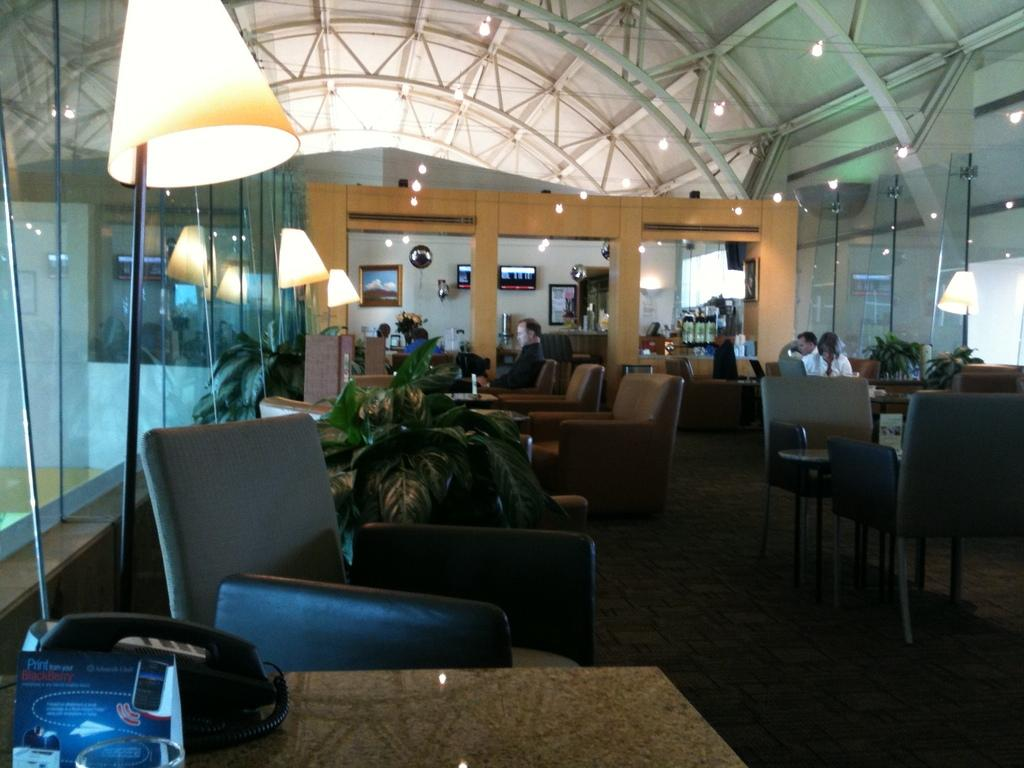What are the persons in the image doing? The persons in the image are sitting on chairs. What type of furniture can be seen in the image? Chairs and tables are visible in the image. What electronic device is present in the image? There is a phone in the image. What type of lighting is present in the image? Lamps are present in the image. What type of vegetation is visible in the image? Plants are visible in the image. What part of the room can be seen in the image? The floor is visible in the image. What type of decorations are on the wall in the background? There are frames and screens on the wall in the background. What type of soup is being served in the image? There is no soup present in the image. What type of notebook is being used by the person sitting on the chair? There is no notebook present in the image. 